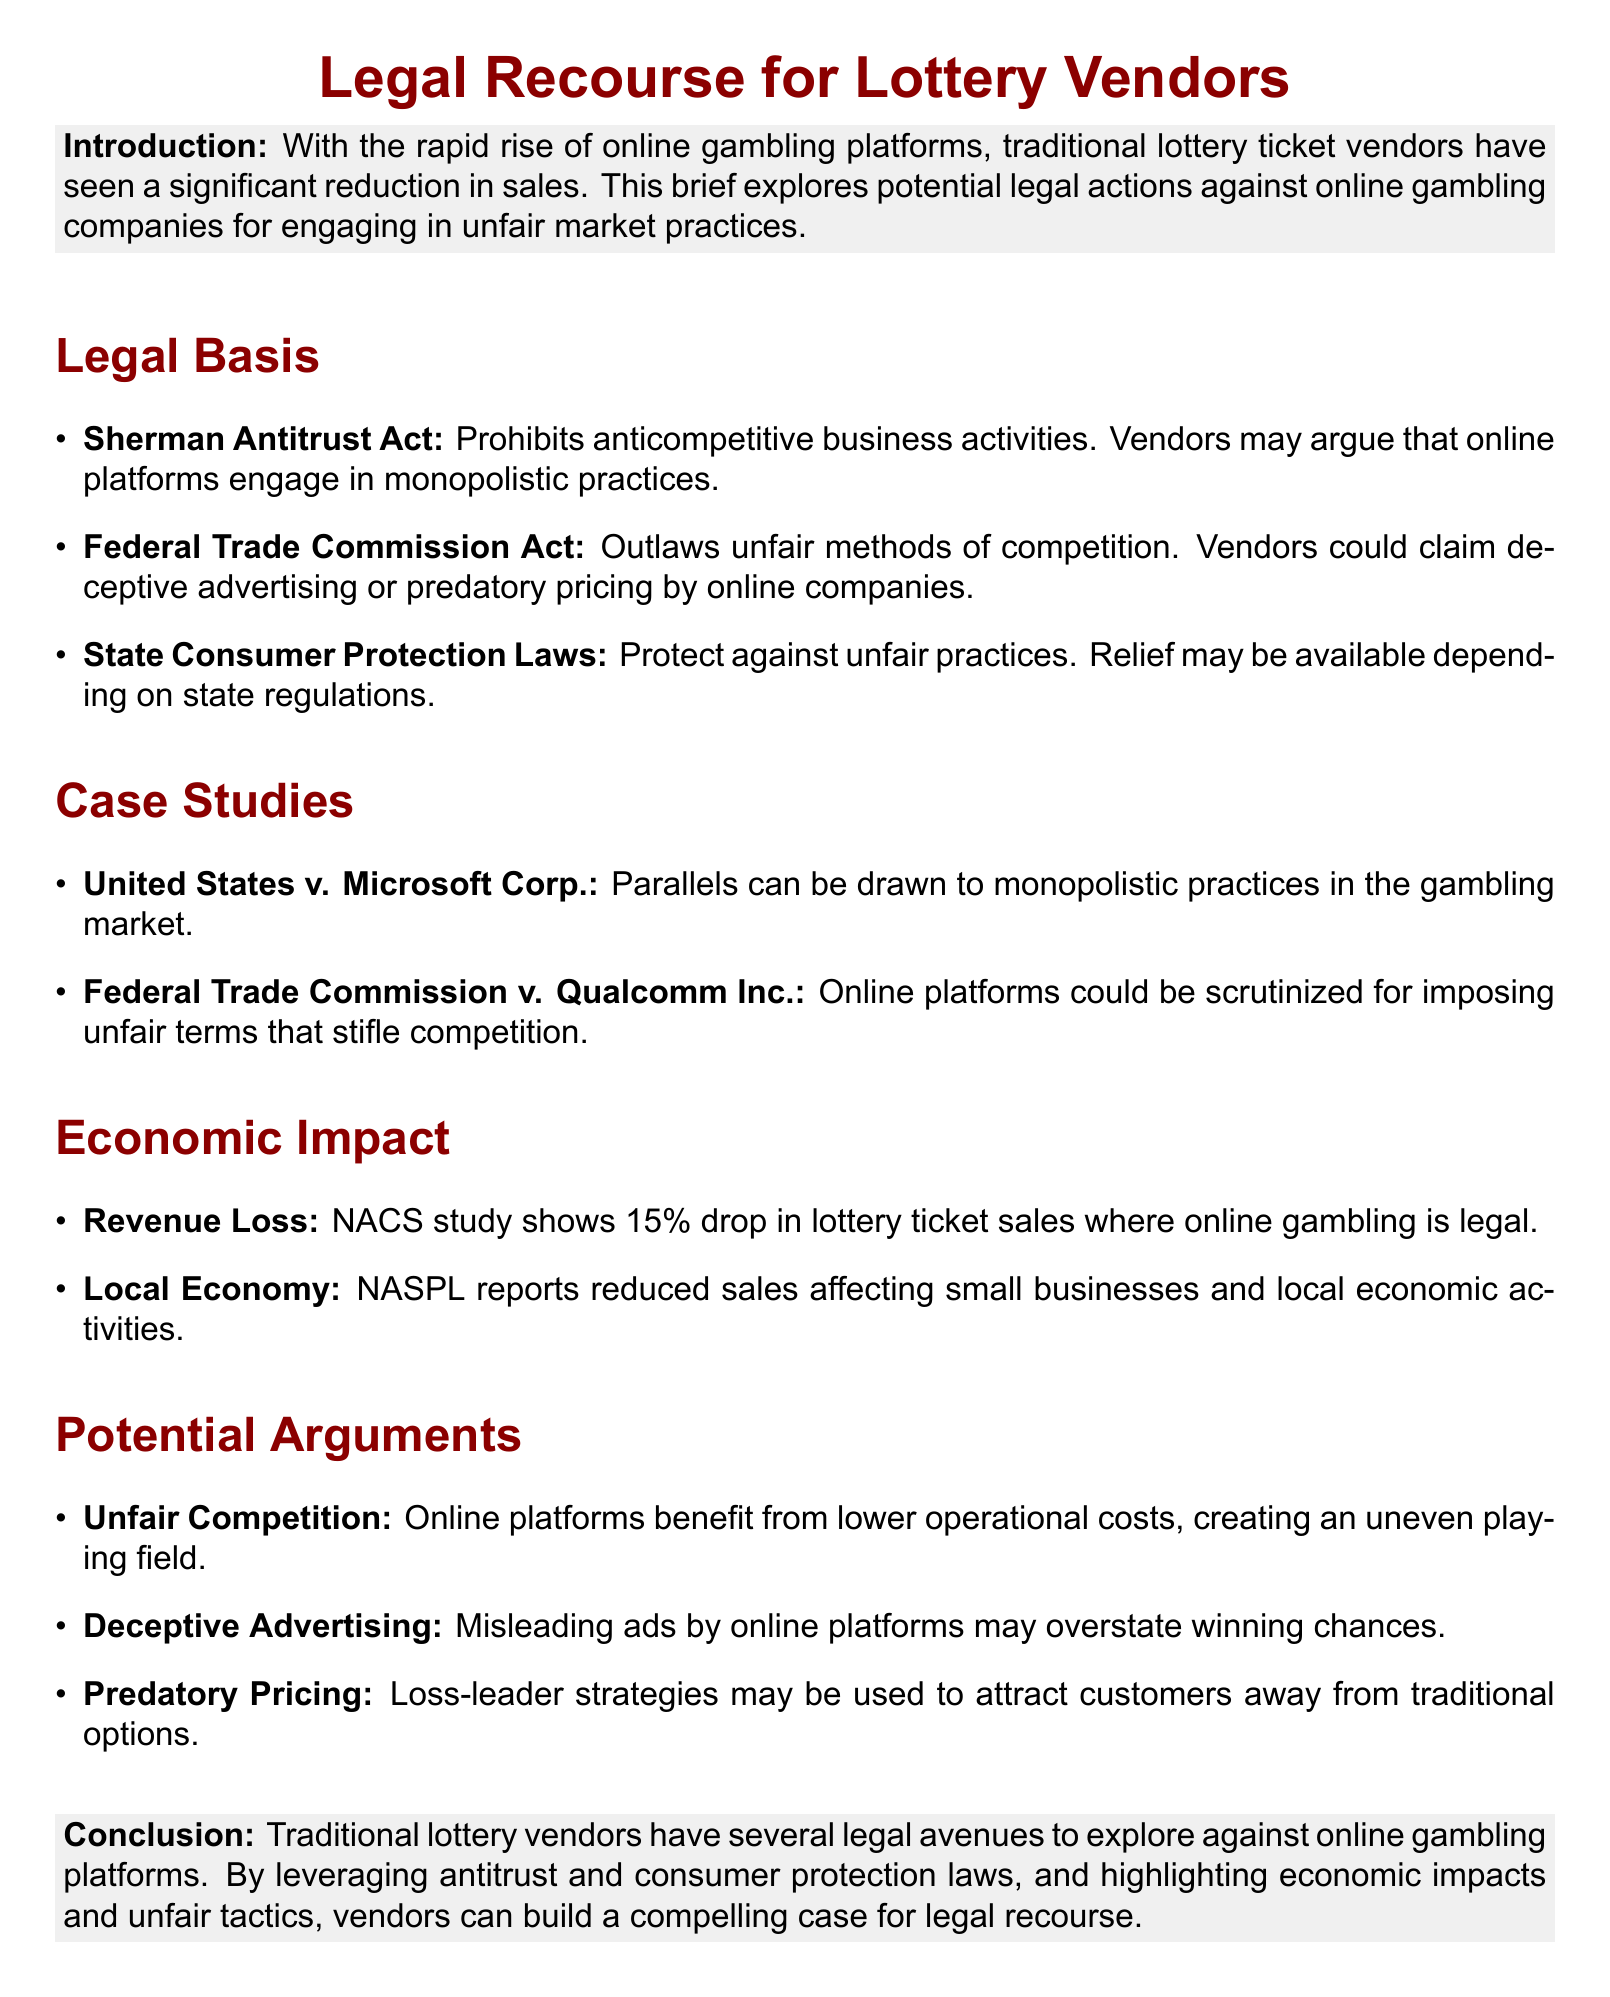What is the legal basis for potential claims? The document outlines several legal bases for potential claims, including the Sherman Antitrust Act, Federal Trade Commission Act, and State Consumer Protection Laws.
Answer: Sherman Antitrust Act, Federal Trade Commission Act, State Consumer Protection Laws What percentage drop in lottery ticket sales is noted? The document cites an NACS study indicating a 15% drop in lottery ticket sales where online gambling is legal.
Answer: 15% Which significant case is referenced to draw parallels with monopolistic practices? The case United States v. Microsoft Corp. is referenced as a comparison to monopolistic practices in the gambling market.
Answer: United States v. Microsoft Corp What are the online platforms accused of using to attract customers? The document states that online platforms may use predatory pricing strategies, specifically loss-leader tactics, to attract customers away from traditional options.
Answer: Predatory pricing What economic consequence is highlighted due to reduced lottery ticket sales? The document notes that reduced sales have a negative impact on small businesses and local economic activities.
Answer: Reduced sales affecting small businesses and local economic activities Which law protects against unfair advertising methods? The Federal Trade Commission Act is mentioned as outlawing unfair methods of competition, including deceptive advertising.
Answer: Federal Trade Commission Act What is one potential argument traditional lottery vendors can make? Traditional lottery vendors can argue that online platforms benefit from lower operational costs, creating an uneven playing field.
Answer: Unfair Competition Which organization reported the impact on the local economy? The National Association of State and Provincial Lotteries (NASPL) reported the economic impacts of reduced sales.
Answer: NASPL 